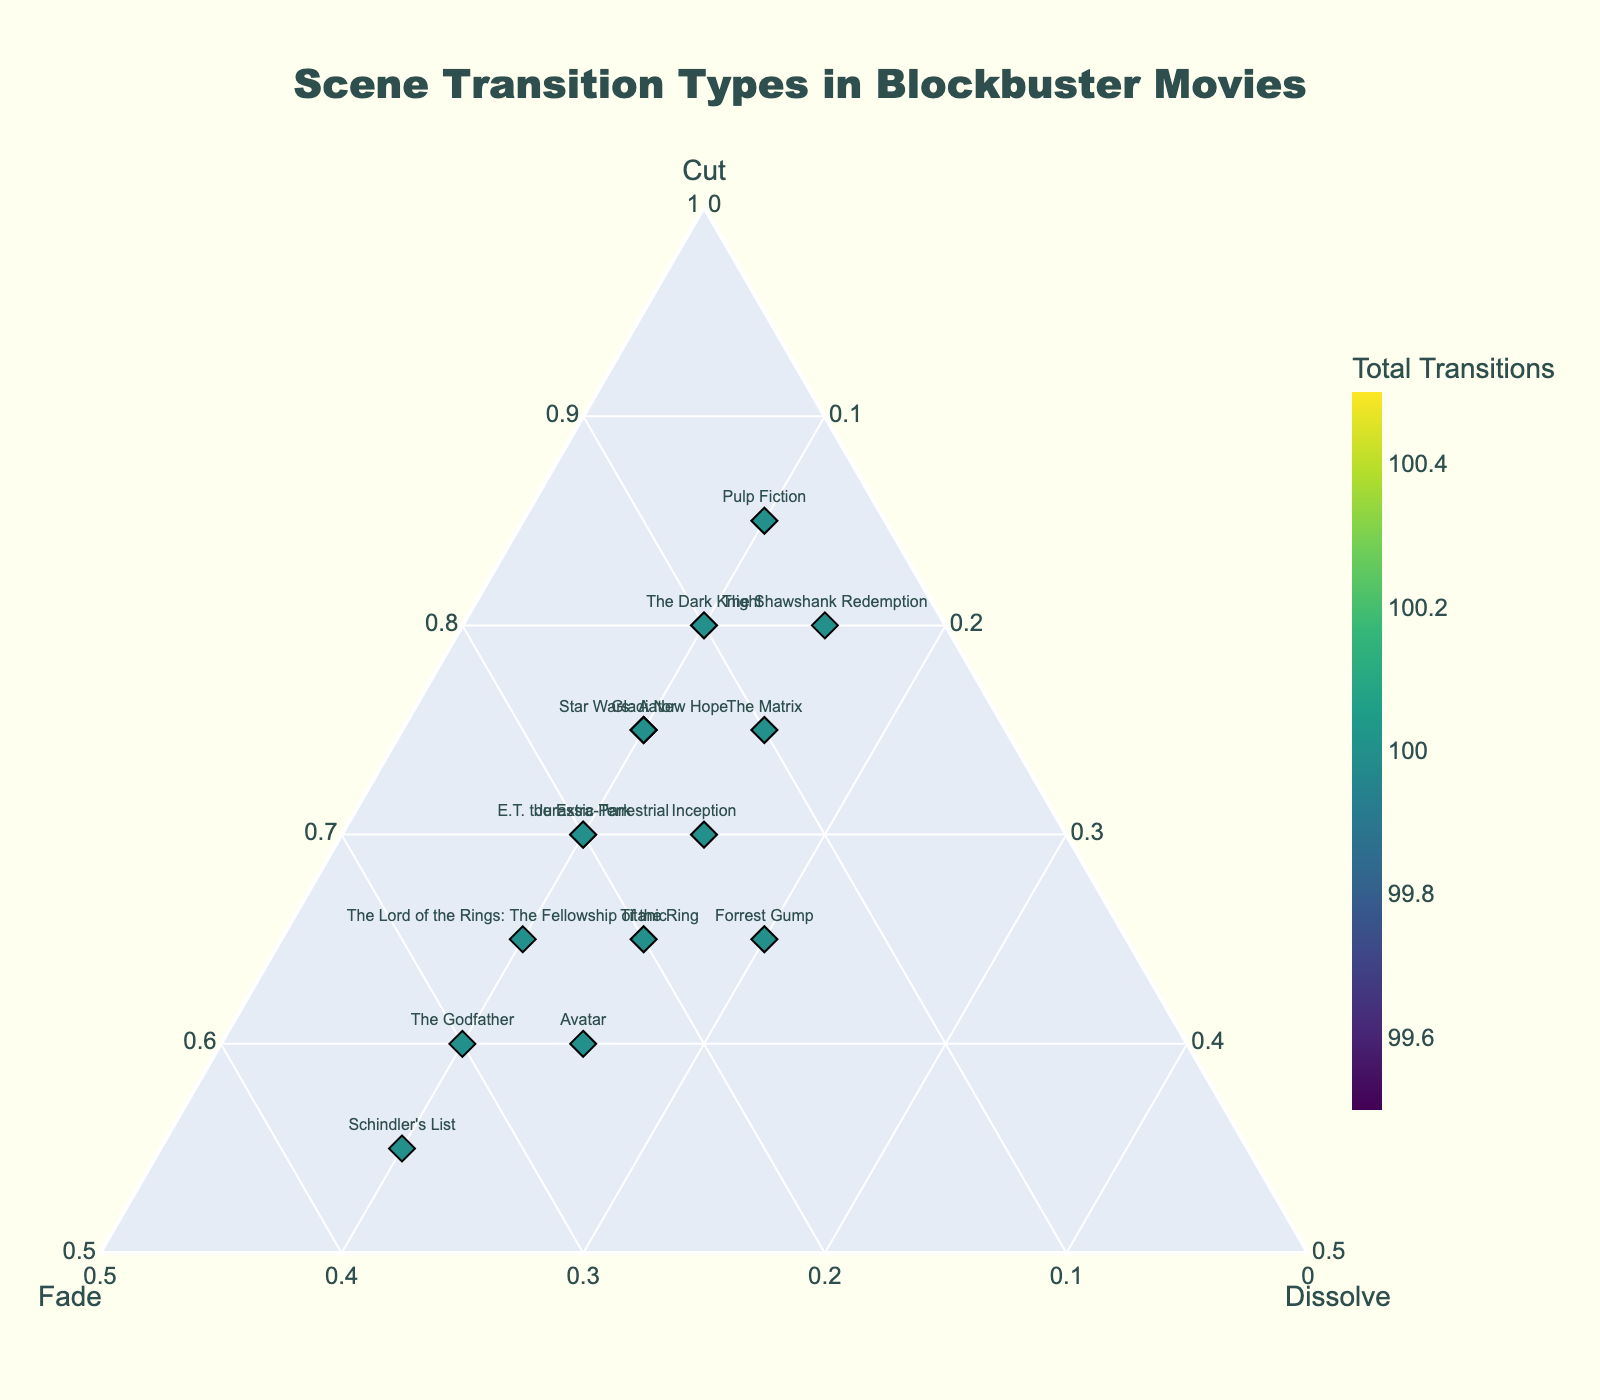How many movies are represented in the plot? Count the total number of data points labeled with movie titles on the plot.
Answer: 15 What is the predominant scene transition type used in "The Dark Knight"? Look at the position of "The Dark Knight" on the ternary plot. Identify which axis ("Cut", "Fade", or "Dissolve") it is closest to.
Answer: Cut Which movie has the highest proportion of Fade transitions? Locate the movie closest to the Fade axis on the plot. The axis with the maximum value represents the highest proportion.
Answer: Schindler's List Do "Avatar" and "Titanic" have similar transition type distributions? Compare the positions of "Avatar" and "Titanic" on the ternary plot. Analyze if they are located near each other, indicating similar proportions of transitions.
Answer: Yes What's the minimum proportion of Cuts for any movie shown? Identify the movie farthest from the Cut axis and check its Cut proportion. This represents the minimum proportion of Cuts.
Answer: 0.55 (Schindler's List) Which movie has an equal proportion of Fades and Dissolves? Identify the movie positioned on the line where the Fade and Dissolve axes intersect equally.
Answer: Inception How do the total number of transitions compare between "The Godfather" and "E.T. the Extra-Terrestrial"? Examine the color intensity of each data point. The movie with the darker color has a higher total number of transitions.
Answer: The Godfather and E.T. the Extra-Terrestrial have the same total number of transitions What is the most common combination of transition types (Cut, Fade, Dissolve) used across all movies? Observe the cluster of data points. The most densely populated area of the plot represents the most common combination.
Answer: Cut-dominant, with moderate Fades and Dissolves Which movie has the smallest proportion of Dissolves? Find the movie closest to the lower part of the Dissolve axis.
Answer: Pulp Fiction What is the average proportion of Cuts across all movies? Sum the proportions of Cuts for all movies and divide by the number of movies, approximately: (0.7+0.8+0.6+0.85+0.65+0.75+0.7+0.6+0.65+0.75+0.8+0.7+0.65+0.55+0.75) / 15. The calculation involves summing the numerical values and dividing by the count.
Answer: 0.705 